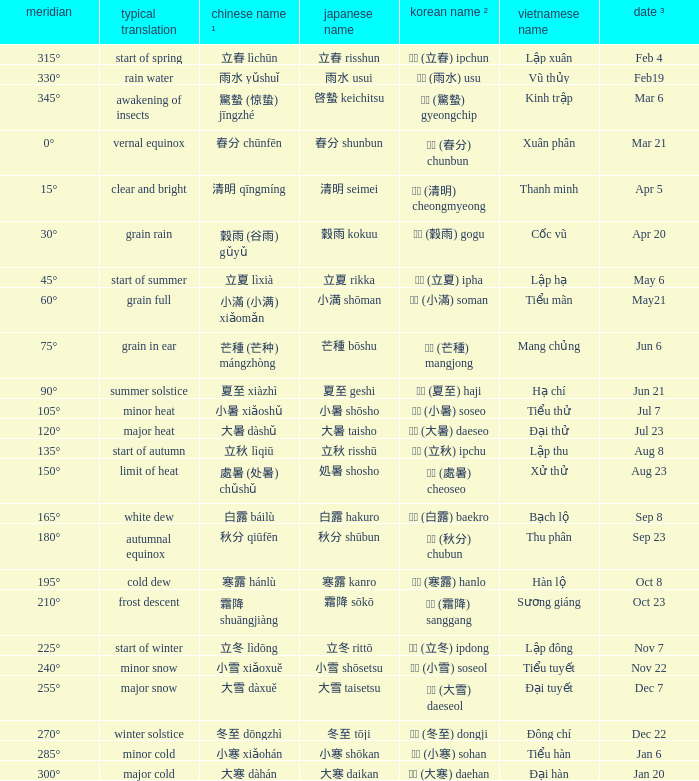WHich Usual translation is on sep 23? Autumnal equinox. 